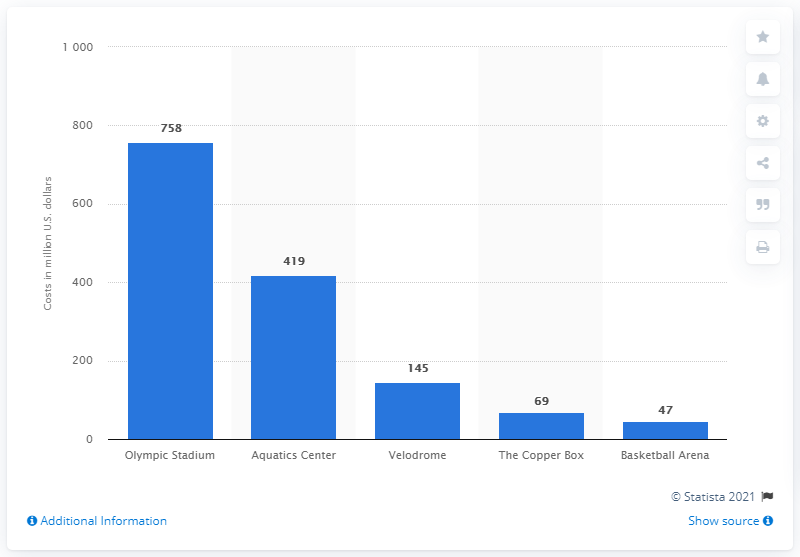How much did the Velodrome cost in US dollars? The Velodrome cost 145 million US dollars, as per the data shown. It's one of the significant investments, though not as high as the Olympic Stadium or Aquatics Center according to the graph. 